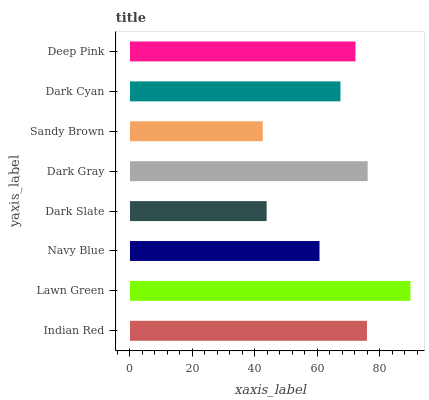Is Sandy Brown the minimum?
Answer yes or no. Yes. Is Lawn Green the maximum?
Answer yes or no. Yes. Is Navy Blue the minimum?
Answer yes or no. No. Is Navy Blue the maximum?
Answer yes or no. No. Is Lawn Green greater than Navy Blue?
Answer yes or no. Yes. Is Navy Blue less than Lawn Green?
Answer yes or no. Yes. Is Navy Blue greater than Lawn Green?
Answer yes or no. No. Is Lawn Green less than Navy Blue?
Answer yes or no. No. Is Deep Pink the high median?
Answer yes or no. Yes. Is Dark Cyan the low median?
Answer yes or no. Yes. Is Dark Gray the high median?
Answer yes or no. No. Is Sandy Brown the low median?
Answer yes or no. No. 